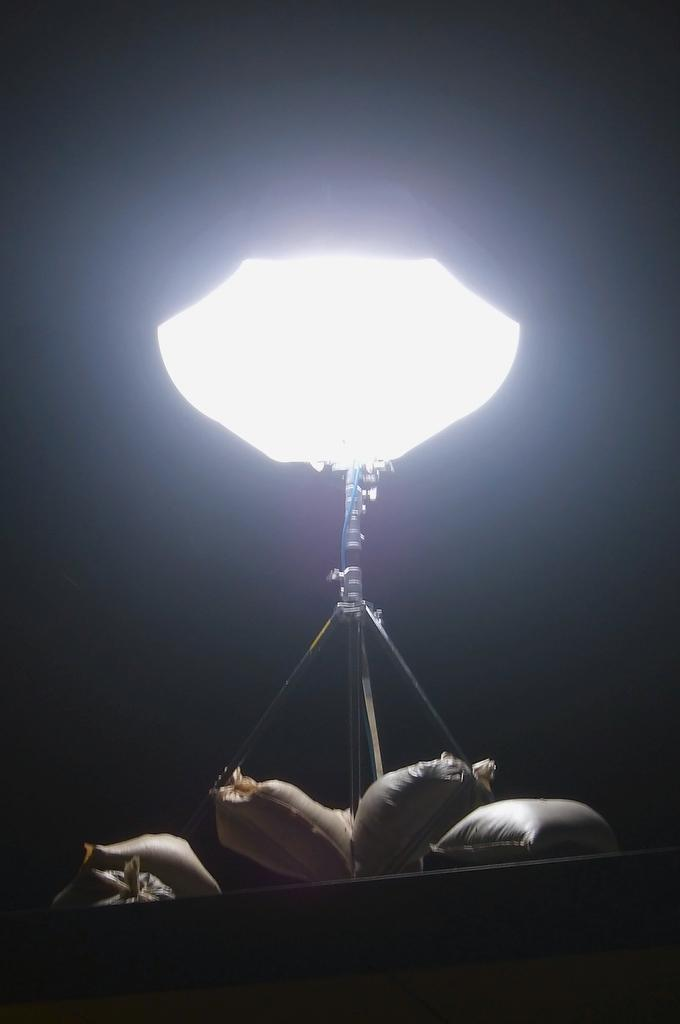What is the main object in the image? There is a light on a stand in the image. What else can be seen on the platform in the image? There are bags on a platform in the image. How would you describe the overall lighting in the image? The background of the image is dark. What direction is the mom walking in the image? There is no mom or any indication of someone walking in the image. 